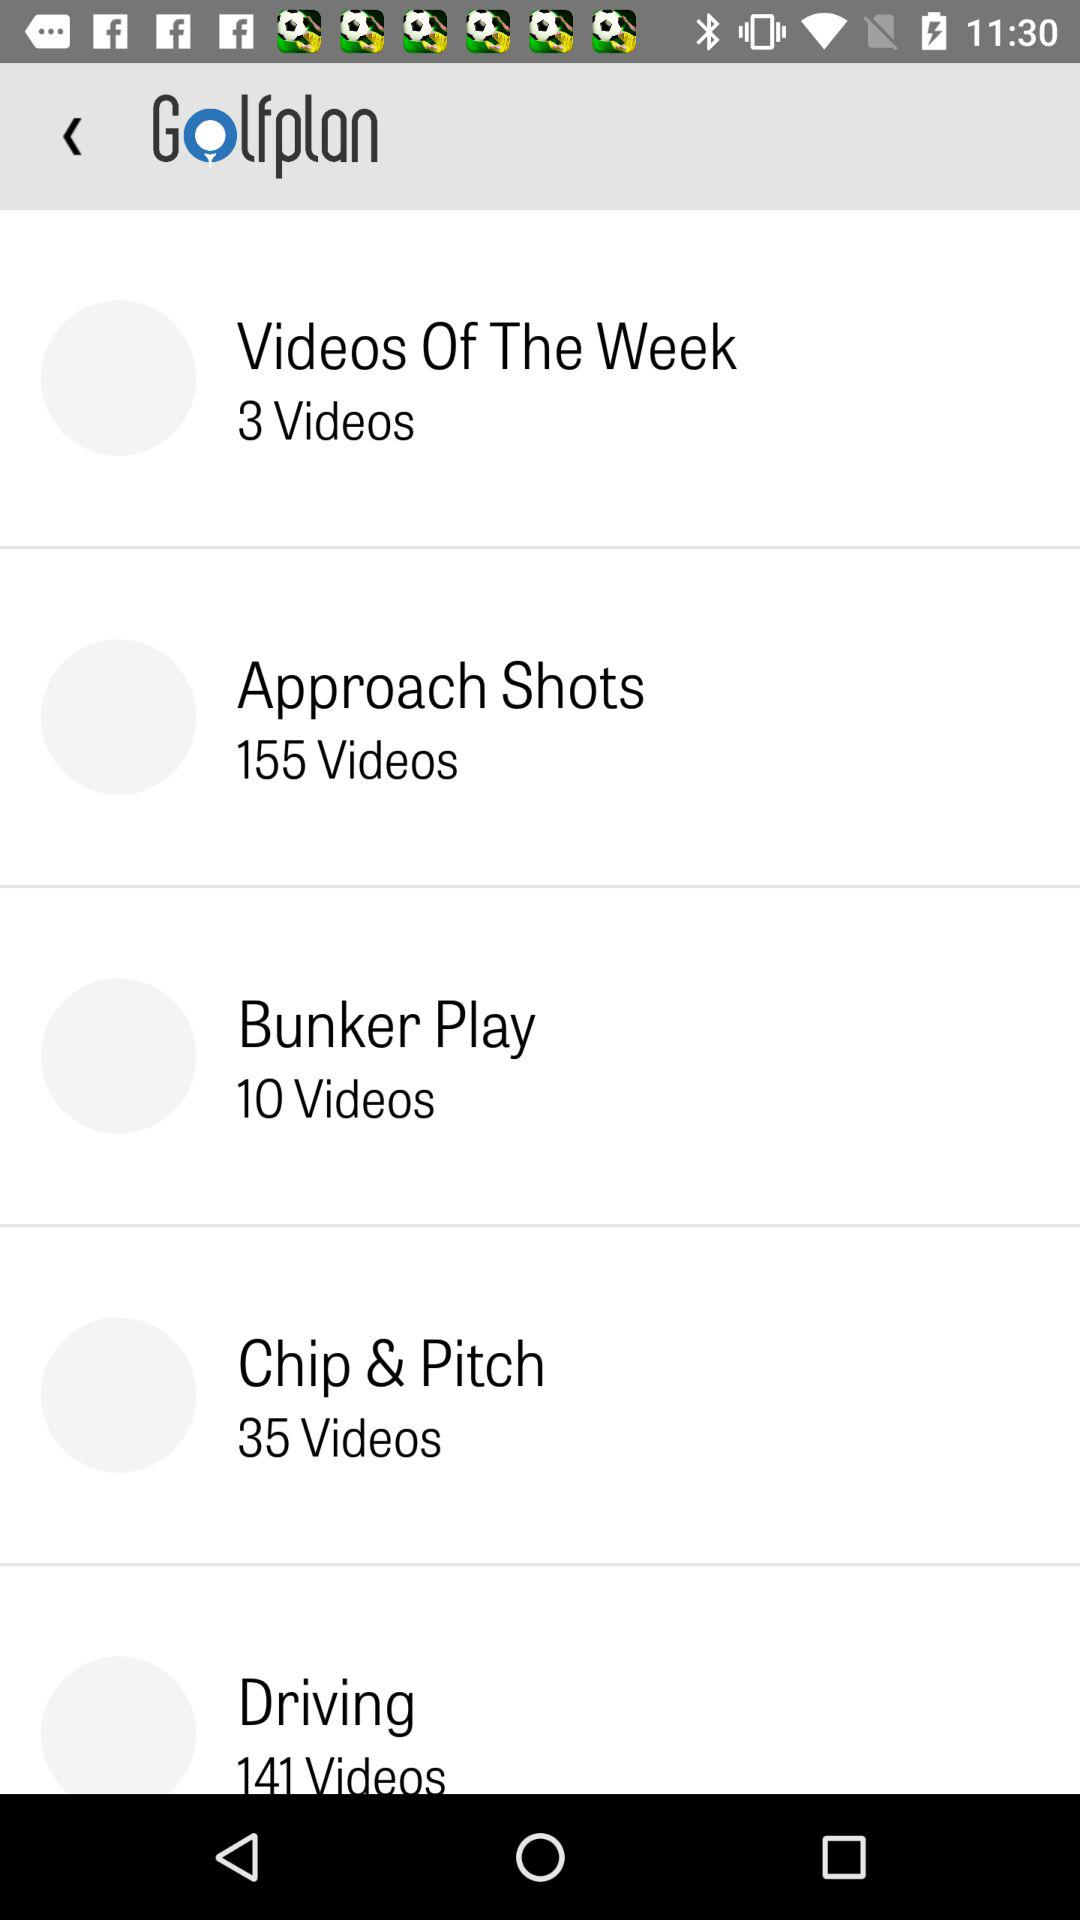Bunker Play contains how many videos? Bunker Play contains 10 videos. 